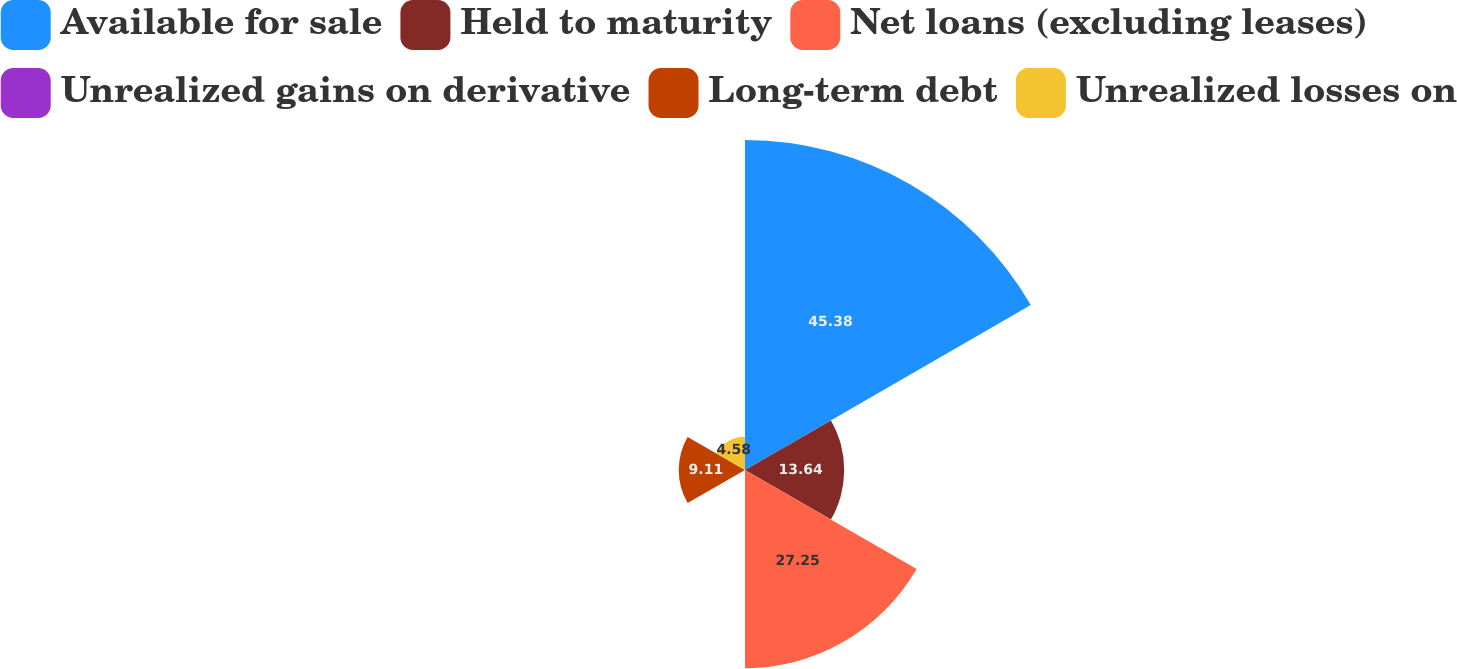Convert chart. <chart><loc_0><loc_0><loc_500><loc_500><pie_chart><fcel>Available for sale<fcel>Held to maturity<fcel>Net loans (excluding leases)<fcel>Unrealized gains on derivative<fcel>Long-term debt<fcel>Unrealized losses on<nl><fcel>45.38%<fcel>13.64%<fcel>27.25%<fcel>0.04%<fcel>9.11%<fcel>4.58%<nl></chart> 